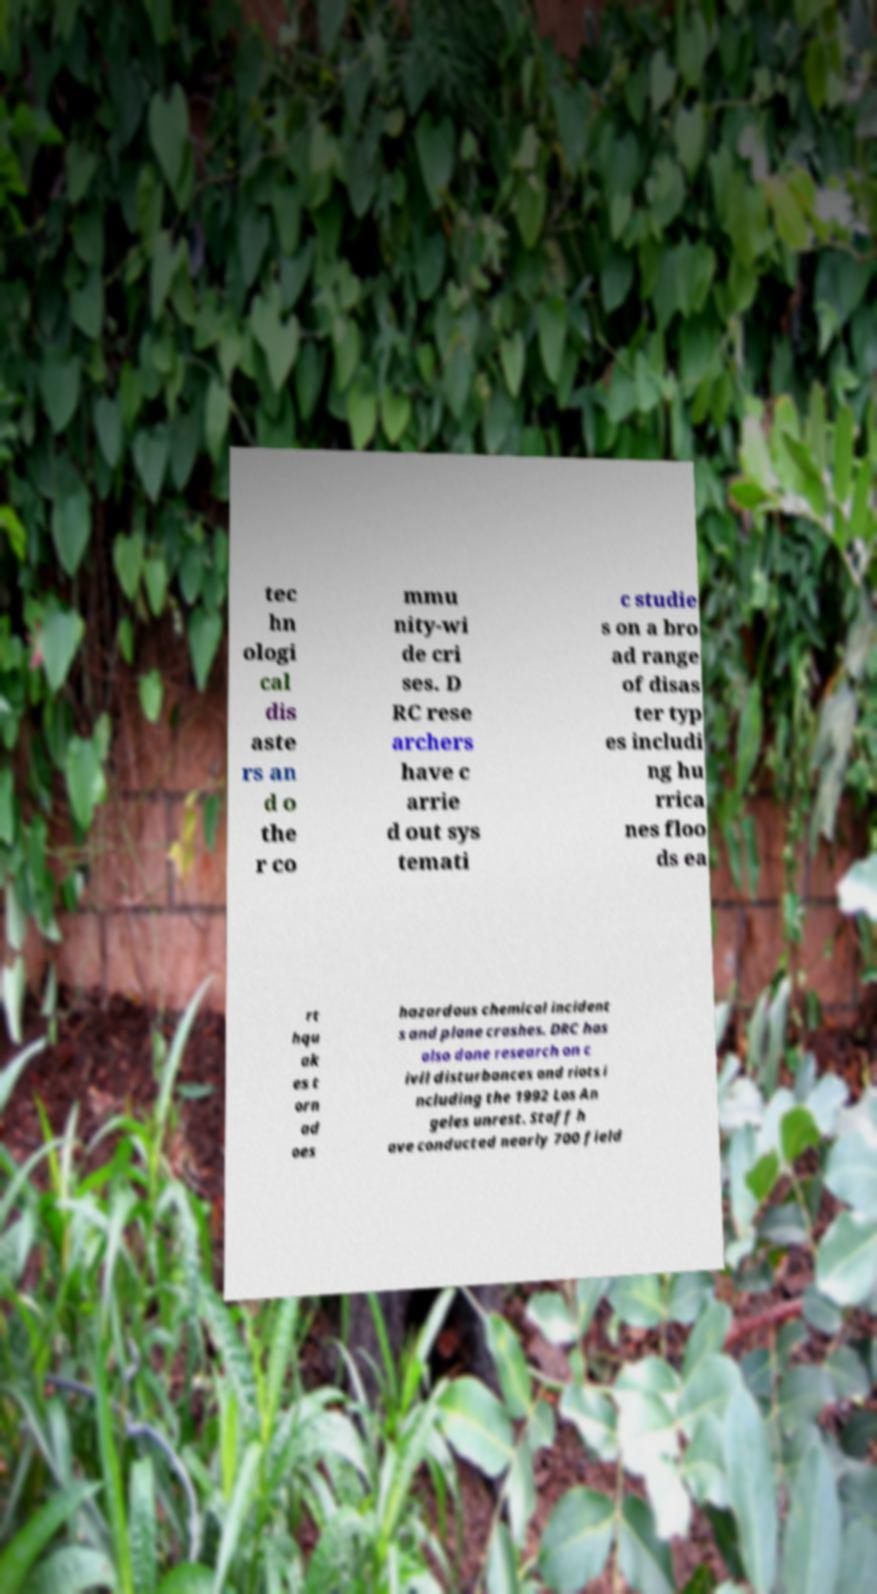There's text embedded in this image that I need extracted. Can you transcribe it verbatim? tec hn ologi cal dis aste rs an d o the r co mmu nity-wi de cri ses. D RC rese archers have c arrie d out sys temati c studie s on a bro ad range of disas ter typ es includi ng hu rrica nes floo ds ea rt hqu ak es t orn ad oes hazardous chemical incident s and plane crashes. DRC has also done research on c ivil disturbances and riots i ncluding the 1992 Los An geles unrest. Staff h ave conducted nearly 700 field 